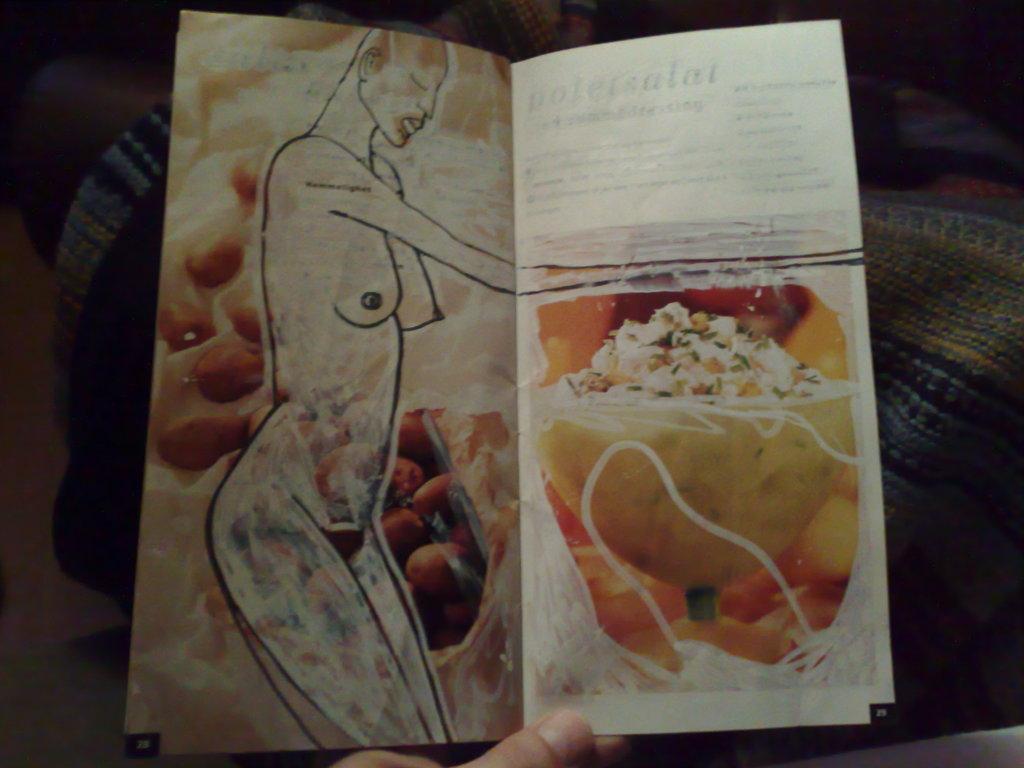Please provide a concise description of this image. In this picture there is a person holding the card. On the card there is a picture of a woman and there is a picture of food and there is text. At the bottom it looks like a cloth and there is a floor. 